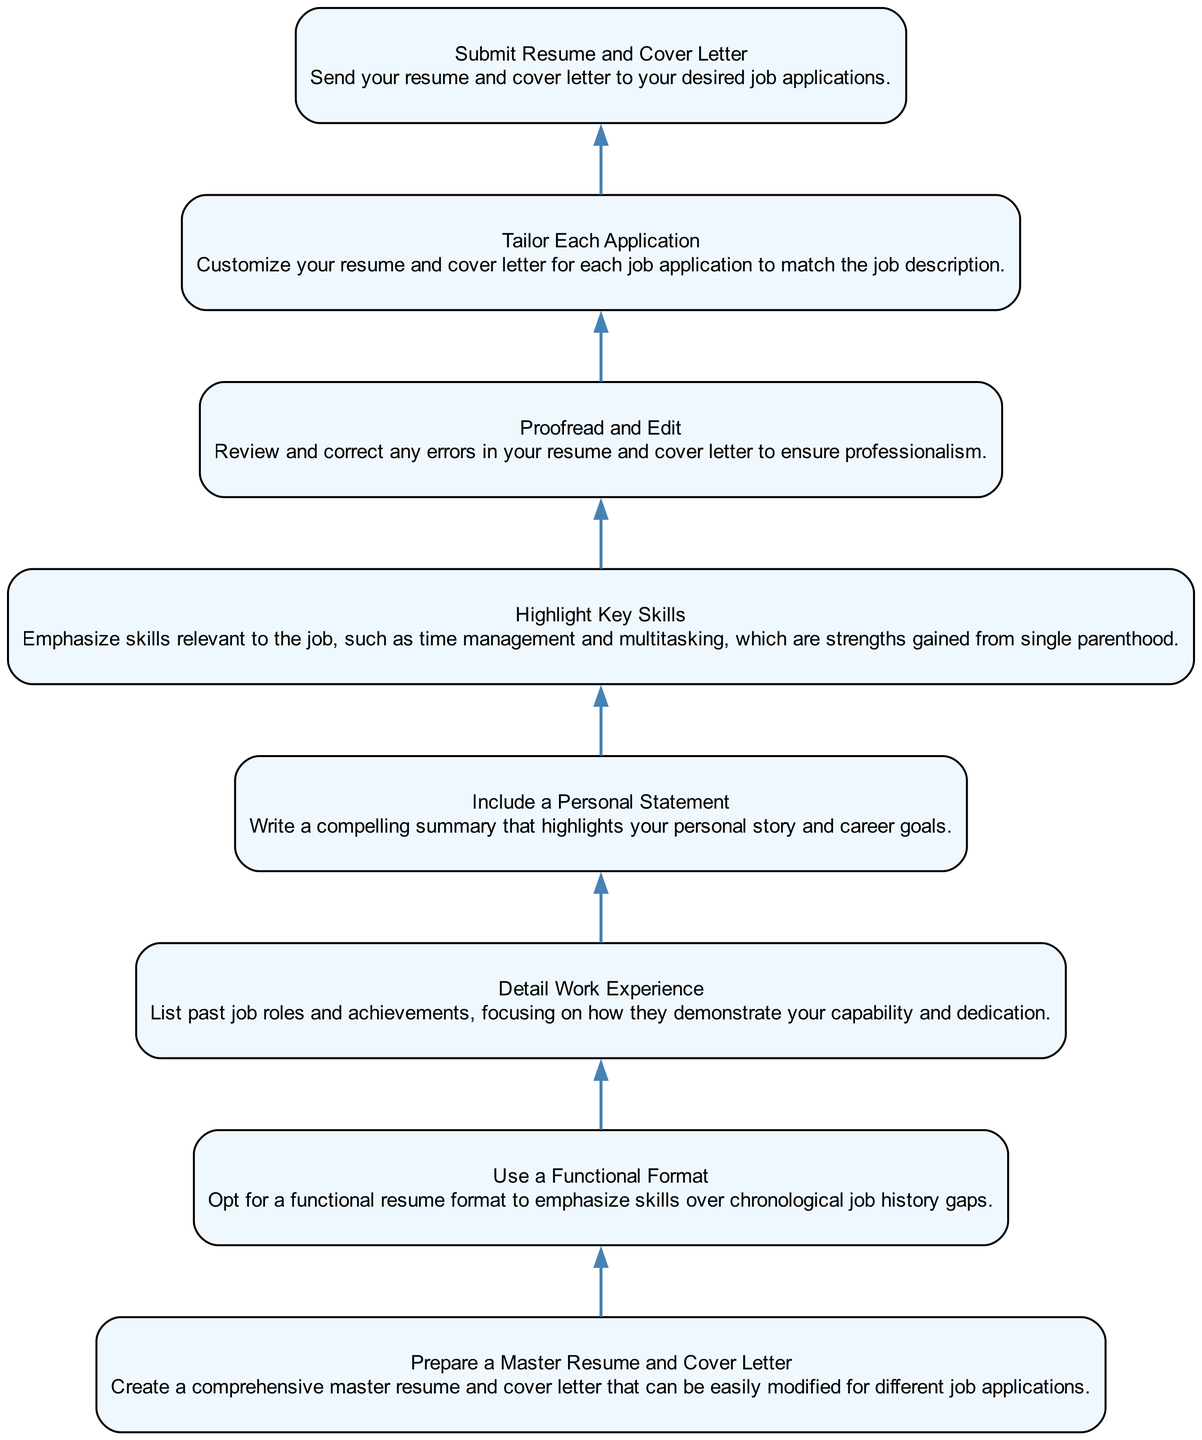What is the first step in the process? The first step is to "Prepare a Master Resume and Cover Letter," which is the node at the bottom of the diagram. This is the starting point for the actions described.
Answer: Prepare a Master Resume and Cover Letter How many total steps are there in the diagram? The diagram has a total of 8 nodes, each representing a step in the process, going from "Prepare a Master Resume and Cover Letter" at the bottom to "Submit Resume and Cover Letter" at the top.
Answer: 8 What is the last action to take before submitting applications? Before submitting applications, the last action is to "Proofread and Edit," which involves checking for errors in the documents to ensure they are professional.
Answer: Proofread and Edit What does the "Highlight Key Skills" step emphasize? The "Highlight Key Skills" step emphasizes skills relevant to the job, specifically pointing out skills like time management and multitasking that are gained from single parenthood.
Answer: Skills relevant to the job Which step comes immediately after "Detail Work Experience"? The step that follows "Detail Work Experience" is "Include a Personal Statement," indicating that after detailing past roles, one should focus on summarizing their personal journey and career objectives.
Answer: Include a Personal Statement What key aspect does the "Use a Functional Format" step address? The "Use a Functional Format" step addresses the strategy of emphasizing skills rather than focusing on gaps in chronological work history, which is particularly relevant for single parents.
Answer: Emphasizing skills How does each application need to be treated according to the diagram? Each application needs to be customized according to the "Tailor Each Application" step, which requires the candidate to align their resume and cover letter with the specific job description for each application.
Answer: Customized What is suggested to be included in the cover letter according to this process? The process suggests including a "Personal Statement" in the cover letter, which highlights the individual’s personal story and career aspirations.
Answer: Personal Statement 